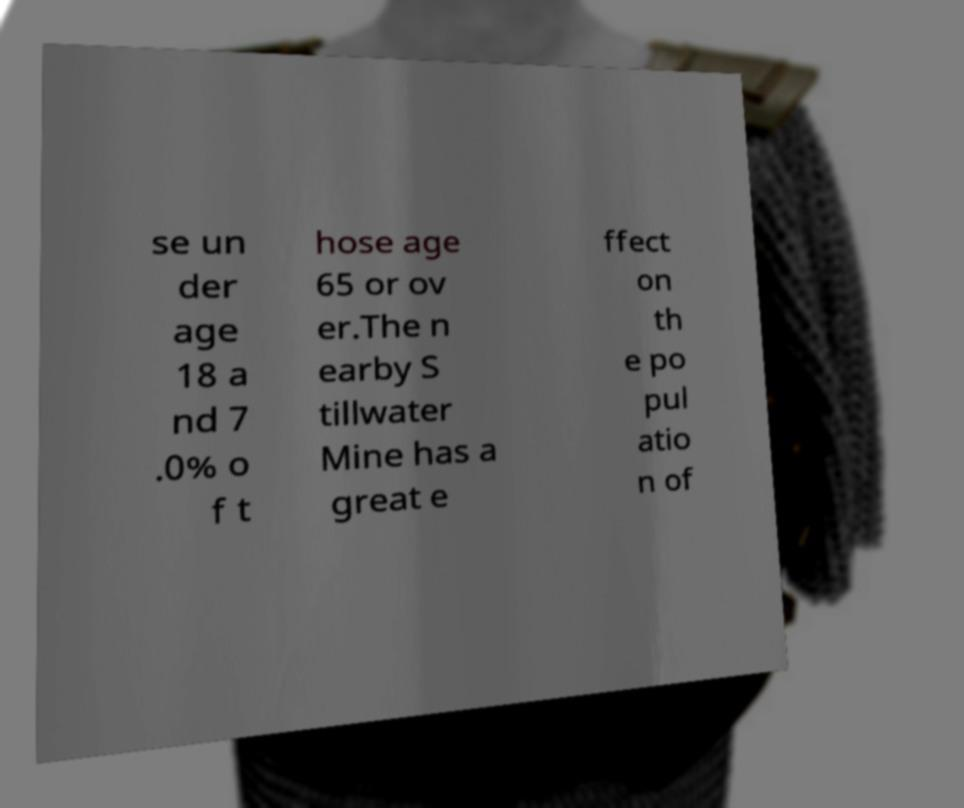There's text embedded in this image that I need extracted. Can you transcribe it verbatim? se un der age 18 a nd 7 .0% o f t hose age 65 or ov er.The n earby S tillwater Mine has a great e ffect on th e po pul atio n of 